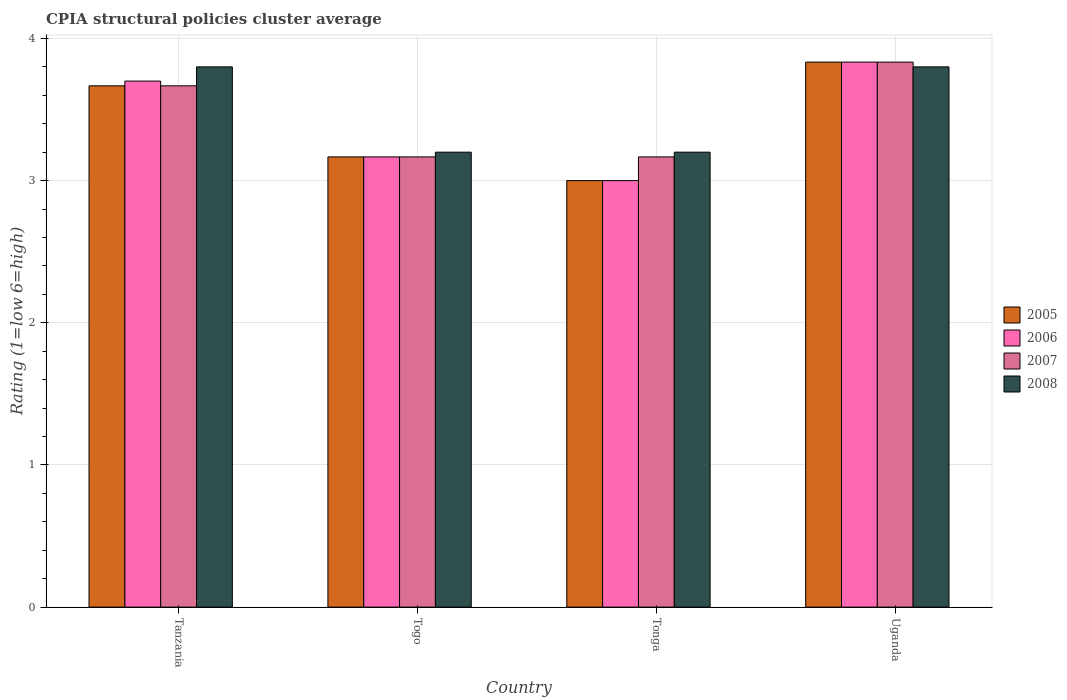Are the number of bars per tick equal to the number of legend labels?
Provide a short and direct response. Yes. Are the number of bars on each tick of the X-axis equal?
Offer a terse response. Yes. How many bars are there on the 1st tick from the left?
Offer a terse response. 4. How many bars are there on the 2nd tick from the right?
Make the answer very short. 4. What is the label of the 1st group of bars from the left?
Give a very brief answer. Tanzania. In how many cases, is the number of bars for a given country not equal to the number of legend labels?
Ensure brevity in your answer.  0. What is the CPIA rating in 2005 in Tanzania?
Give a very brief answer. 3.67. Across all countries, what is the maximum CPIA rating in 2005?
Offer a very short reply. 3.83. Across all countries, what is the minimum CPIA rating in 2008?
Your answer should be compact. 3.2. In which country was the CPIA rating in 2007 maximum?
Make the answer very short. Uganda. In which country was the CPIA rating in 2008 minimum?
Offer a terse response. Togo. What is the total CPIA rating in 2007 in the graph?
Provide a short and direct response. 13.83. What is the difference between the CPIA rating in 2008 in Togo and that in Tonga?
Make the answer very short. 0. What is the difference between the CPIA rating in 2005 in Uganda and the CPIA rating in 2006 in Tanzania?
Keep it short and to the point. 0.13. What is the average CPIA rating in 2005 per country?
Keep it short and to the point. 3.42. What is the difference between the CPIA rating of/in 2008 and CPIA rating of/in 2006 in Tanzania?
Your response must be concise. 0.1. What is the ratio of the CPIA rating in 2005 in Tonga to that in Uganda?
Provide a short and direct response. 0.78. Is the CPIA rating in 2007 in Togo less than that in Tonga?
Provide a succinct answer. No. What is the difference between the highest and the second highest CPIA rating in 2006?
Offer a very short reply. -0.13. What is the difference between the highest and the lowest CPIA rating in 2008?
Keep it short and to the point. 0.6. Is the sum of the CPIA rating in 2008 in Togo and Tonga greater than the maximum CPIA rating in 2005 across all countries?
Your answer should be compact. Yes. Is it the case that in every country, the sum of the CPIA rating in 2007 and CPIA rating in 2005 is greater than the sum of CPIA rating in 2008 and CPIA rating in 2006?
Ensure brevity in your answer.  No. Is it the case that in every country, the sum of the CPIA rating in 2005 and CPIA rating in 2006 is greater than the CPIA rating in 2007?
Make the answer very short. Yes. How many bars are there?
Ensure brevity in your answer.  16. Are all the bars in the graph horizontal?
Offer a very short reply. No. How many countries are there in the graph?
Ensure brevity in your answer.  4. What is the difference between two consecutive major ticks on the Y-axis?
Your answer should be compact. 1. Are the values on the major ticks of Y-axis written in scientific E-notation?
Provide a short and direct response. No. Does the graph contain any zero values?
Offer a very short reply. No. How many legend labels are there?
Ensure brevity in your answer.  4. How are the legend labels stacked?
Give a very brief answer. Vertical. What is the title of the graph?
Make the answer very short. CPIA structural policies cluster average. What is the Rating (1=low 6=high) in 2005 in Tanzania?
Give a very brief answer. 3.67. What is the Rating (1=low 6=high) of 2006 in Tanzania?
Keep it short and to the point. 3.7. What is the Rating (1=low 6=high) in 2007 in Tanzania?
Offer a very short reply. 3.67. What is the Rating (1=low 6=high) of 2008 in Tanzania?
Offer a very short reply. 3.8. What is the Rating (1=low 6=high) of 2005 in Togo?
Make the answer very short. 3.17. What is the Rating (1=low 6=high) in 2006 in Togo?
Offer a very short reply. 3.17. What is the Rating (1=low 6=high) of 2007 in Togo?
Make the answer very short. 3.17. What is the Rating (1=low 6=high) in 2005 in Tonga?
Ensure brevity in your answer.  3. What is the Rating (1=low 6=high) of 2006 in Tonga?
Your answer should be very brief. 3. What is the Rating (1=low 6=high) in 2007 in Tonga?
Offer a very short reply. 3.17. What is the Rating (1=low 6=high) of 2008 in Tonga?
Your answer should be compact. 3.2. What is the Rating (1=low 6=high) of 2005 in Uganda?
Give a very brief answer. 3.83. What is the Rating (1=low 6=high) of 2006 in Uganda?
Your response must be concise. 3.83. What is the Rating (1=low 6=high) of 2007 in Uganda?
Offer a very short reply. 3.83. Across all countries, what is the maximum Rating (1=low 6=high) of 2005?
Provide a short and direct response. 3.83. Across all countries, what is the maximum Rating (1=low 6=high) in 2006?
Offer a terse response. 3.83. Across all countries, what is the maximum Rating (1=low 6=high) of 2007?
Offer a terse response. 3.83. Across all countries, what is the maximum Rating (1=low 6=high) of 2008?
Your answer should be very brief. 3.8. Across all countries, what is the minimum Rating (1=low 6=high) in 2005?
Provide a short and direct response. 3. Across all countries, what is the minimum Rating (1=low 6=high) in 2006?
Give a very brief answer. 3. Across all countries, what is the minimum Rating (1=low 6=high) of 2007?
Ensure brevity in your answer.  3.17. What is the total Rating (1=low 6=high) of 2005 in the graph?
Offer a terse response. 13.67. What is the total Rating (1=low 6=high) of 2006 in the graph?
Offer a terse response. 13.7. What is the total Rating (1=low 6=high) in 2007 in the graph?
Keep it short and to the point. 13.83. What is the total Rating (1=low 6=high) of 2008 in the graph?
Provide a short and direct response. 14. What is the difference between the Rating (1=low 6=high) in 2005 in Tanzania and that in Togo?
Your answer should be very brief. 0.5. What is the difference between the Rating (1=low 6=high) in 2006 in Tanzania and that in Togo?
Your answer should be compact. 0.53. What is the difference between the Rating (1=low 6=high) in 2008 in Tanzania and that in Togo?
Give a very brief answer. 0.6. What is the difference between the Rating (1=low 6=high) in 2005 in Tanzania and that in Tonga?
Ensure brevity in your answer.  0.67. What is the difference between the Rating (1=low 6=high) of 2006 in Tanzania and that in Tonga?
Your response must be concise. 0.7. What is the difference between the Rating (1=low 6=high) in 2007 in Tanzania and that in Tonga?
Give a very brief answer. 0.5. What is the difference between the Rating (1=low 6=high) in 2006 in Tanzania and that in Uganda?
Your response must be concise. -0.13. What is the difference between the Rating (1=low 6=high) in 2007 in Tanzania and that in Uganda?
Provide a short and direct response. -0.17. What is the difference between the Rating (1=low 6=high) of 2006 in Togo and that in Tonga?
Offer a terse response. 0.17. What is the difference between the Rating (1=low 6=high) in 2007 in Togo and that in Tonga?
Provide a short and direct response. 0. What is the difference between the Rating (1=low 6=high) of 2008 in Togo and that in Tonga?
Provide a succinct answer. 0. What is the difference between the Rating (1=low 6=high) of 2006 in Togo and that in Uganda?
Provide a succinct answer. -0.67. What is the difference between the Rating (1=low 6=high) in 2005 in Tonga and that in Uganda?
Make the answer very short. -0.83. What is the difference between the Rating (1=low 6=high) of 2008 in Tonga and that in Uganda?
Your response must be concise. -0.6. What is the difference between the Rating (1=low 6=high) in 2005 in Tanzania and the Rating (1=low 6=high) in 2008 in Togo?
Make the answer very short. 0.47. What is the difference between the Rating (1=low 6=high) of 2006 in Tanzania and the Rating (1=low 6=high) of 2007 in Togo?
Provide a succinct answer. 0.53. What is the difference between the Rating (1=low 6=high) in 2007 in Tanzania and the Rating (1=low 6=high) in 2008 in Togo?
Offer a very short reply. 0.47. What is the difference between the Rating (1=low 6=high) in 2005 in Tanzania and the Rating (1=low 6=high) in 2006 in Tonga?
Keep it short and to the point. 0.67. What is the difference between the Rating (1=low 6=high) in 2005 in Tanzania and the Rating (1=low 6=high) in 2008 in Tonga?
Keep it short and to the point. 0.47. What is the difference between the Rating (1=low 6=high) of 2006 in Tanzania and the Rating (1=low 6=high) of 2007 in Tonga?
Give a very brief answer. 0.53. What is the difference between the Rating (1=low 6=high) of 2006 in Tanzania and the Rating (1=low 6=high) of 2008 in Tonga?
Provide a short and direct response. 0.5. What is the difference between the Rating (1=low 6=high) of 2007 in Tanzania and the Rating (1=low 6=high) of 2008 in Tonga?
Provide a succinct answer. 0.47. What is the difference between the Rating (1=low 6=high) of 2005 in Tanzania and the Rating (1=low 6=high) of 2006 in Uganda?
Your answer should be compact. -0.17. What is the difference between the Rating (1=low 6=high) of 2005 in Tanzania and the Rating (1=low 6=high) of 2007 in Uganda?
Your answer should be very brief. -0.17. What is the difference between the Rating (1=low 6=high) in 2005 in Tanzania and the Rating (1=low 6=high) in 2008 in Uganda?
Provide a short and direct response. -0.13. What is the difference between the Rating (1=low 6=high) of 2006 in Tanzania and the Rating (1=low 6=high) of 2007 in Uganda?
Your answer should be very brief. -0.13. What is the difference between the Rating (1=low 6=high) of 2006 in Tanzania and the Rating (1=low 6=high) of 2008 in Uganda?
Your answer should be very brief. -0.1. What is the difference between the Rating (1=low 6=high) of 2007 in Tanzania and the Rating (1=low 6=high) of 2008 in Uganda?
Make the answer very short. -0.13. What is the difference between the Rating (1=low 6=high) of 2005 in Togo and the Rating (1=low 6=high) of 2006 in Tonga?
Your answer should be very brief. 0.17. What is the difference between the Rating (1=low 6=high) of 2005 in Togo and the Rating (1=low 6=high) of 2007 in Tonga?
Your answer should be very brief. 0. What is the difference between the Rating (1=low 6=high) in 2005 in Togo and the Rating (1=low 6=high) in 2008 in Tonga?
Ensure brevity in your answer.  -0.03. What is the difference between the Rating (1=low 6=high) in 2006 in Togo and the Rating (1=low 6=high) in 2008 in Tonga?
Make the answer very short. -0.03. What is the difference between the Rating (1=low 6=high) in 2007 in Togo and the Rating (1=low 6=high) in 2008 in Tonga?
Make the answer very short. -0.03. What is the difference between the Rating (1=low 6=high) in 2005 in Togo and the Rating (1=low 6=high) in 2006 in Uganda?
Keep it short and to the point. -0.67. What is the difference between the Rating (1=low 6=high) in 2005 in Togo and the Rating (1=low 6=high) in 2008 in Uganda?
Offer a terse response. -0.63. What is the difference between the Rating (1=low 6=high) of 2006 in Togo and the Rating (1=low 6=high) of 2007 in Uganda?
Your answer should be compact. -0.67. What is the difference between the Rating (1=low 6=high) of 2006 in Togo and the Rating (1=low 6=high) of 2008 in Uganda?
Provide a short and direct response. -0.63. What is the difference between the Rating (1=low 6=high) of 2007 in Togo and the Rating (1=low 6=high) of 2008 in Uganda?
Provide a succinct answer. -0.63. What is the difference between the Rating (1=low 6=high) in 2005 in Tonga and the Rating (1=low 6=high) in 2008 in Uganda?
Your response must be concise. -0.8. What is the difference between the Rating (1=low 6=high) of 2006 in Tonga and the Rating (1=low 6=high) of 2007 in Uganda?
Your response must be concise. -0.83. What is the difference between the Rating (1=low 6=high) of 2007 in Tonga and the Rating (1=low 6=high) of 2008 in Uganda?
Give a very brief answer. -0.63. What is the average Rating (1=low 6=high) of 2005 per country?
Keep it short and to the point. 3.42. What is the average Rating (1=low 6=high) of 2006 per country?
Provide a short and direct response. 3.42. What is the average Rating (1=low 6=high) of 2007 per country?
Give a very brief answer. 3.46. What is the average Rating (1=low 6=high) of 2008 per country?
Your response must be concise. 3.5. What is the difference between the Rating (1=low 6=high) in 2005 and Rating (1=low 6=high) in 2006 in Tanzania?
Make the answer very short. -0.03. What is the difference between the Rating (1=low 6=high) in 2005 and Rating (1=low 6=high) in 2007 in Tanzania?
Your answer should be compact. 0. What is the difference between the Rating (1=low 6=high) of 2005 and Rating (1=low 6=high) of 2008 in Tanzania?
Provide a succinct answer. -0.13. What is the difference between the Rating (1=low 6=high) of 2006 and Rating (1=low 6=high) of 2007 in Tanzania?
Make the answer very short. 0.03. What is the difference between the Rating (1=low 6=high) in 2006 and Rating (1=low 6=high) in 2008 in Tanzania?
Your answer should be compact. -0.1. What is the difference between the Rating (1=low 6=high) of 2007 and Rating (1=low 6=high) of 2008 in Tanzania?
Keep it short and to the point. -0.13. What is the difference between the Rating (1=low 6=high) of 2005 and Rating (1=low 6=high) of 2006 in Togo?
Your answer should be compact. 0. What is the difference between the Rating (1=low 6=high) of 2005 and Rating (1=low 6=high) of 2007 in Togo?
Provide a short and direct response. 0. What is the difference between the Rating (1=low 6=high) of 2005 and Rating (1=low 6=high) of 2008 in Togo?
Provide a succinct answer. -0.03. What is the difference between the Rating (1=low 6=high) of 2006 and Rating (1=low 6=high) of 2008 in Togo?
Keep it short and to the point. -0.03. What is the difference between the Rating (1=low 6=high) of 2007 and Rating (1=low 6=high) of 2008 in Togo?
Offer a very short reply. -0.03. What is the difference between the Rating (1=low 6=high) of 2005 and Rating (1=low 6=high) of 2006 in Tonga?
Keep it short and to the point. 0. What is the difference between the Rating (1=low 6=high) of 2005 and Rating (1=low 6=high) of 2007 in Tonga?
Your response must be concise. -0.17. What is the difference between the Rating (1=low 6=high) of 2006 and Rating (1=low 6=high) of 2007 in Tonga?
Provide a short and direct response. -0.17. What is the difference between the Rating (1=low 6=high) of 2007 and Rating (1=low 6=high) of 2008 in Tonga?
Keep it short and to the point. -0.03. What is the difference between the Rating (1=low 6=high) in 2006 and Rating (1=low 6=high) in 2008 in Uganda?
Provide a short and direct response. 0.03. What is the ratio of the Rating (1=low 6=high) of 2005 in Tanzania to that in Togo?
Offer a terse response. 1.16. What is the ratio of the Rating (1=low 6=high) in 2006 in Tanzania to that in Togo?
Make the answer very short. 1.17. What is the ratio of the Rating (1=low 6=high) of 2007 in Tanzania to that in Togo?
Your response must be concise. 1.16. What is the ratio of the Rating (1=low 6=high) in 2008 in Tanzania to that in Togo?
Make the answer very short. 1.19. What is the ratio of the Rating (1=low 6=high) of 2005 in Tanzania to that in Tonga?
Keep it short and to the point. 1.22. What is the ratio of the Rating (1=low 6=high) of 2006 in Tanzania to that in Tonga?
Give a very brief answer. 1.23. What is the ratio of the Rating (1=low 6=high) of 2007 in Tanzania to that in Tonga?
Give a very brief answer. 1.16. What is the ratio of the Rating (1=low 6=high) in 2008 in Tanzania to that in Tonga?
Provide a short and direct response. 1.19. What is the ratio of the Rating (1=low 6=high) in 2005 in Tanzania to that in Uganda?
Give a very brief answer. 0.96. What is the ratio of the Rating (1=low 6=high) in 2006 in Tanzania to that in Uganda?
Keep it short and to the point. 0.97. What is the ratio of the Rating (1=low 6=high) in 2007 in Tanzania to that in Uganda?
Give a very brief answer. 0.96. What is the ratio of the Rating (1=low 6=high) of 2008 in Tanzania to that in Uganda?
Your response must be concise. 1. What is the ratio of the Rating (1=low 6=high) of 2005 in Togo to that in Tonga?
Your answer should be compact. 1.06. What is the ratio of the Rating (1=low 6=high) in 2006 in Togo to that in Tonga?
Offer a terse response. 1.06. What is the ratio of the Rating (1=low 6=high) of 2005 in Togo to that in Uganda?
Make the answer very short. 0.83. What is the ratio of the Rating (1=low 6=high) in 2006 in Togo to that in Uganda?
Offer a terse response. 0.83. What is the ratio of the Rating (1=low 6=high) of 2007 in Togo to that in Uganda?
Provide a succinct answer. 0.83. What is the ratio of the Rating (1=low 6=high) of 2008 in Togo to that in Uganda?
Your response must be concise. 0.84. What is the ratio of the Rating (1=low 6=high) in 2005 in Tonga to that in Uganda?
Ensure brevity in your answer.  0.78. What is the ratio of the Rating (1=low 6=high) in 2006 in Tonga to that in Uganda?
Provide a short and direct response. 0.78. What is the ratio of the Rating (1=low 6=high) in 2007 in Tonga to that in Uganda?
Ensure brevity in your answer.  0.83. What is the ratio of the Rating (1=low 6=high) of 2008 in Tonga to that in Uganda?
Your answer should be very brief. 0.84. What is the difference between the highest and the second highest Rating (1=low 6=high) of 2005?
Keep it short and to the point. 0.17. What is the difference between the highest and the second highest Rating (1=low 6=high) of 2006?
Your answer should be compact. 0.13. What is the difference between the highest and the second highest Rating (1=low 6=high) in 2007?
Your answer should be very brief. 0.17. What is the difference between the highest and the second highest Rating (1=low 6=high) of 2008?
Your answer should be compact. 0. What is the difference between the highest and the lowest Rating (1=low 6=high) in 2005?
Keep it short and to the point. 0.83. What is the difference between the highest and the lowest Rating (1=low 6=high) in 2007?
Keep it short and to the point. 0.67. 